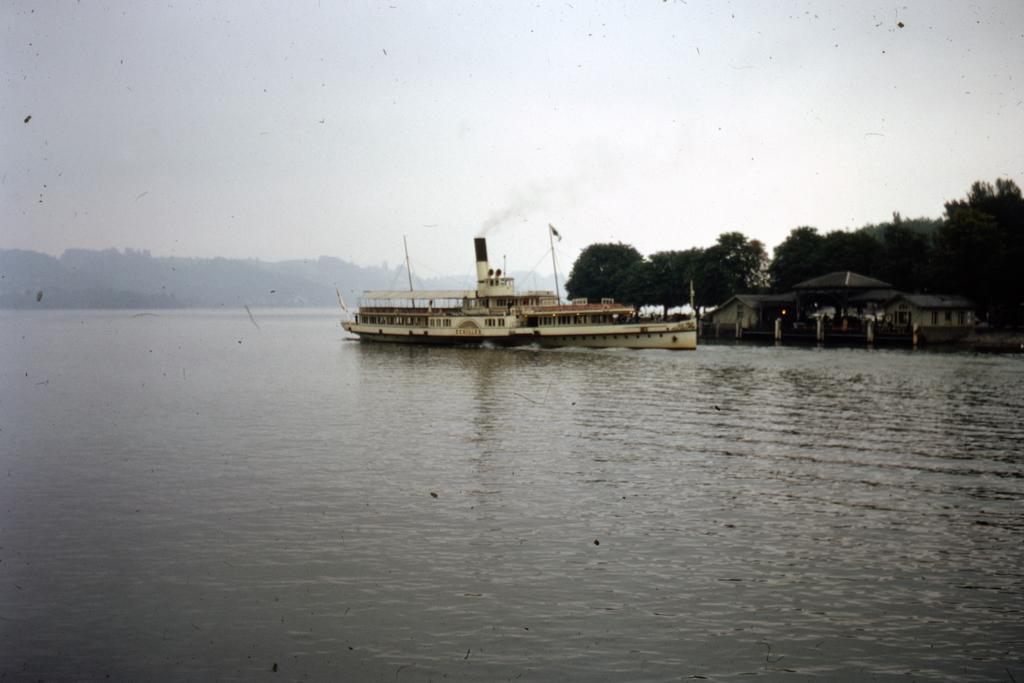What is the main subject of the picture? The main subject of the picture is a boat. Where is the boat located in the picture? The boat is on the water in the picture. What can be seen in the background of the picture? In the background of the picture, there are trees, the sky, houses, and other objects. Can you describe the presence of smoke in the background? Yes, there is smoke present in the background of the picture. What type of wine is being served at the committee meeting in the picture? There is no committee meeting or wine present in the image; it features a boat on the water with a background of trees, sky, houses, and other objects. 